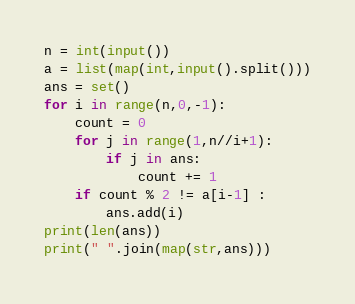Convert code to text. <code><loc_0><loc_0><loc_500><loc_500><_Python_>n = int(input())
a = list(map(int,input().split()))
ans = set()
for i in range(n,0,-1):
    count = 0
    for j in range(1,n//i+1):
        if j in ans:
            count += 1
    if count % 2 != a[i-1] :
        ans.add(i)
print(len(ans))
print(" ".join(map(str,ans))) 
</code> 